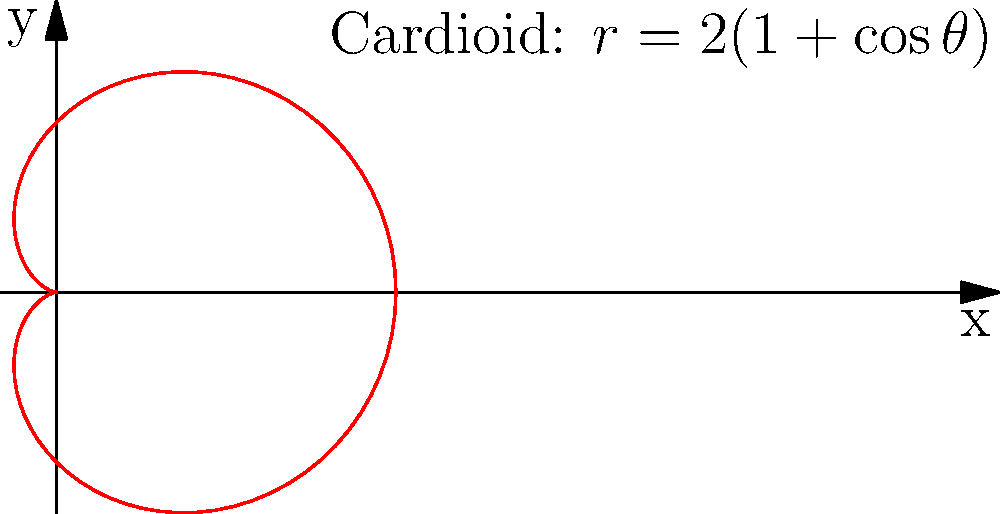Consider the cardioid curve given by the polar equation $r = 2(1 + \cos\theta)$. Determine the area enclosed by this curve and express it in terms of $\pi$. How does this result challenge our intuition about the relationship between geometry and calculus? To find the area enclosed by the cardioid, we'll use the formula for area in polar coordinates and follow these steps:

1) The area formula in polar coordinates is:
   $$A = \frac{1}{2} \int_{0}^{2\pi} r^2(\theta) d\theta$$

2) Substituting our equation $r = 2(1 + \cos\theta)$:
   $$A = \frac{1}{2} \int_{0}^{2\pi} [2(1 + \cos\theta)]^2 d\theta$$

3) Expanding the squared term:
   $$A = 2 \int_{0}^{2\pi} (1 + 2\cos\theta + \cos^2\theta) d\theta$$

4) Using the identity $\cos^2\theta = \frac{1 + \cos(2\theta)}{2}$:
   $$A = 2 \int_{0}^{2\pi} (1 + 2\cos\theta + \frac{1 + \cos(2\theta)}{2}) d\theta$$

5) Simplifying:
   $$A = 2 \int_{0}^{2\pi} (\frac{3}{2} + 2\cos\theta + \frac{\cos(2\theta)}{2}) d\theta$$

6) Integrating term by term:
   $$A = 2 [\frac{3}{2}\theta + 2\sin\theta + \frac{\sin(2\theta)}{4}]_{0}^{2\pi}$$

7) Evaluating the limits:
   $$A = 2 [\frac{3}{2}(2\pi) + 0 + 0] = 6\pi$$

This result challenges our intuition about geometry and calculus in several ways:

1) Despite the curve's complex shape, the area is a simple multiple of $\pi$.
2) The area is exactly three times that of the circle with diameter equal to the cardioid's width (which would be $2\pi$).
3) This demonstrates how calculus can simplify complex geometric problems, revealing unexpected relationships.
4) It shows how polar coordinates can sometimes lead to more elegant solutions than Cartesian coordinates for certain curves.
Answer: $6\pi$ 